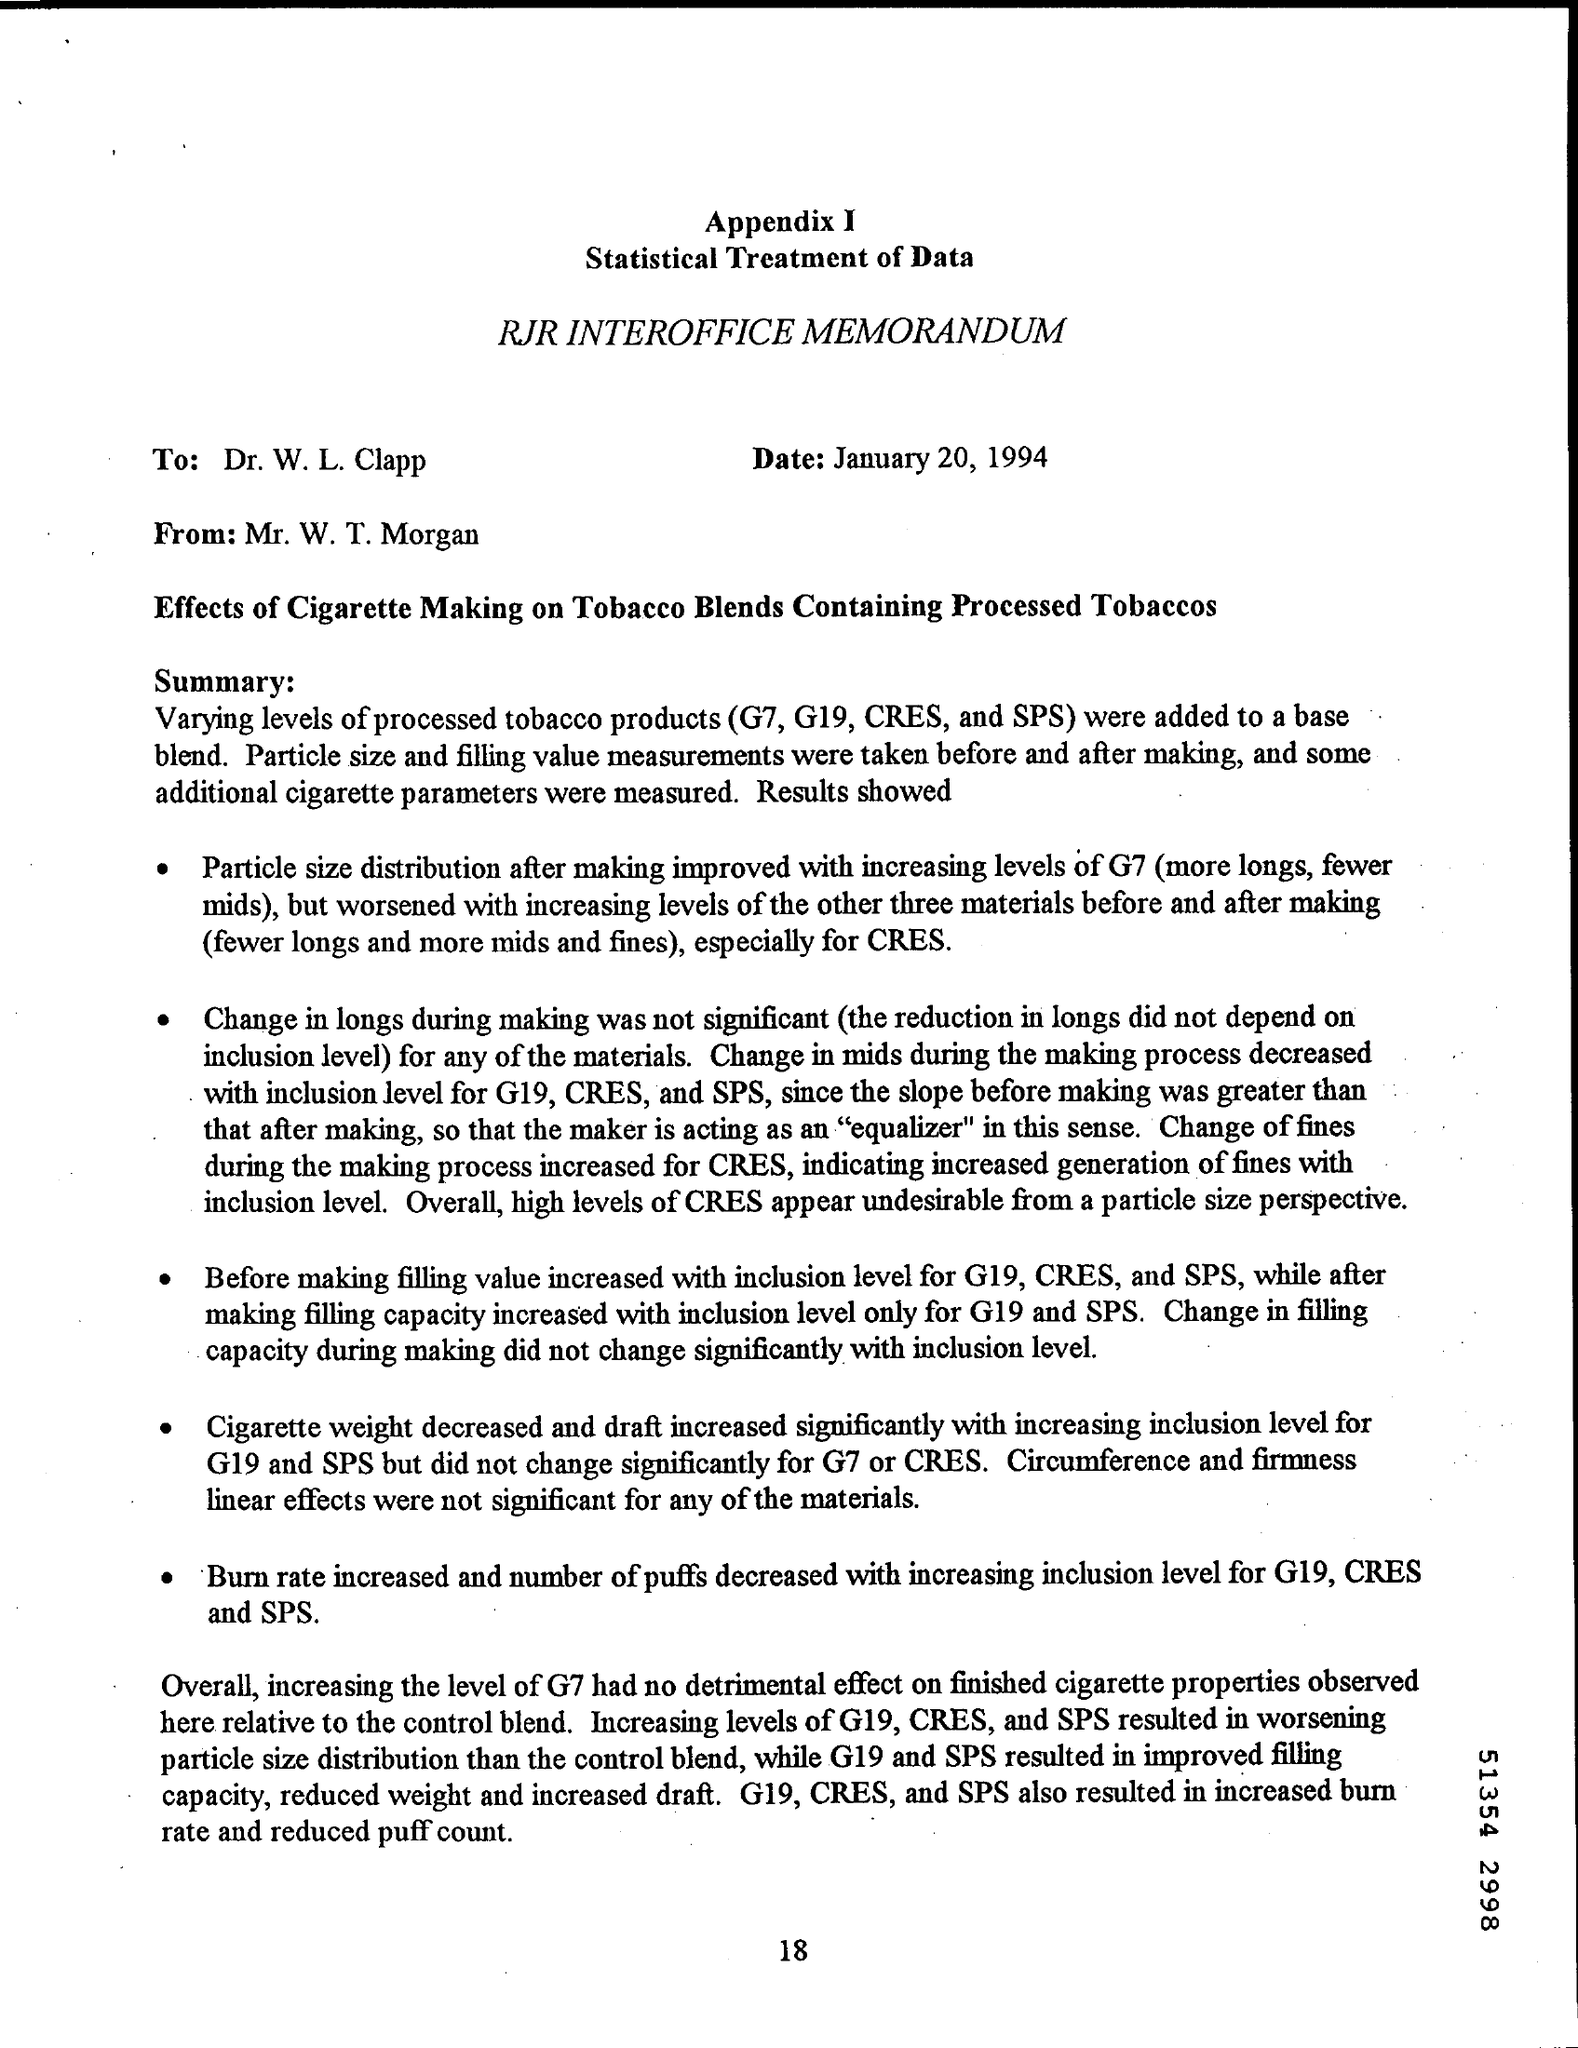What are the products added to base blend?
Provide a short and direct response. G7, G19, CRES, and SPS. Who received the data from Mr. W. T .Morgan?
Provide a short and direct response. Dr. W. L. Clapp. What is the effect on Particle size distribution when CRES levels increased?
Keep it short and to the point. Worsened. Whats the result when inclusion level for G19,CRES AND SPS increased?
Provide a short and direct response. Burn rate increased and number of puffs decreased. 